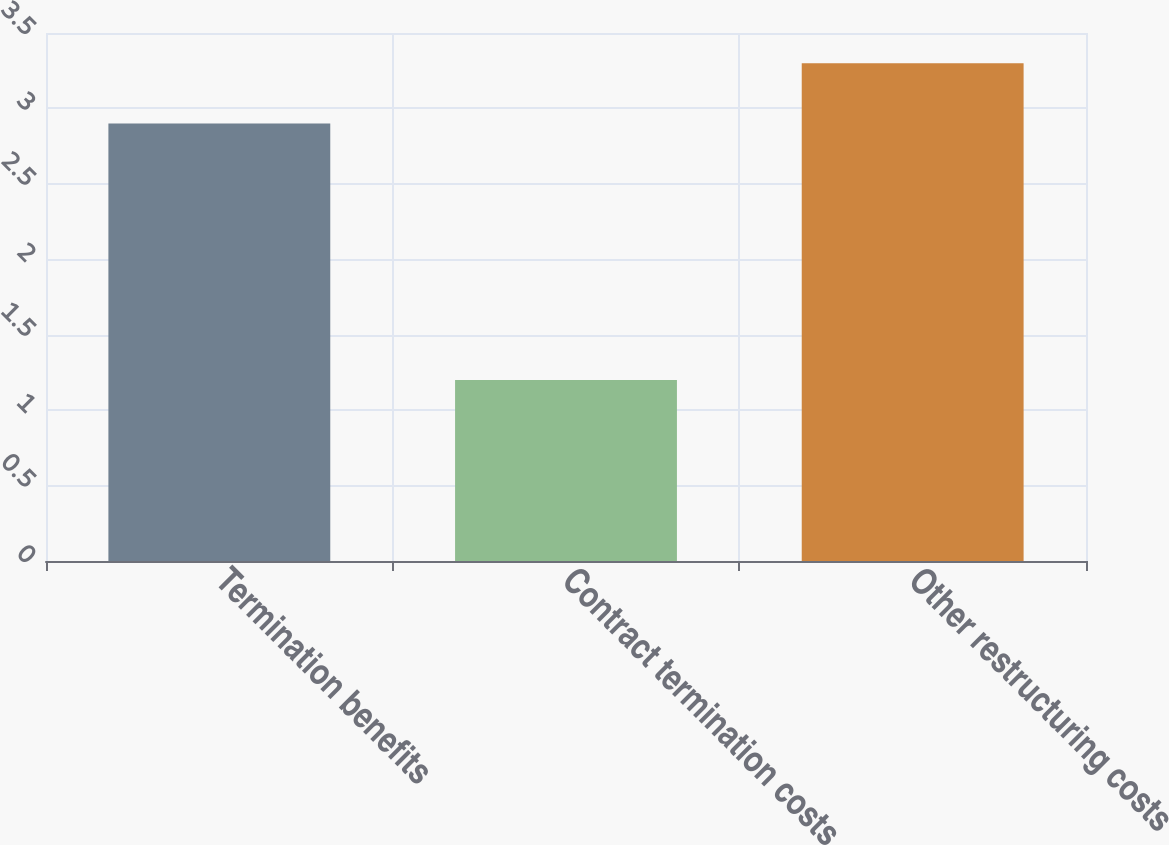Convert chart to OTSL. <chart><loc_0><loc_0><loc_500><loc_500><bar_chart><fcel>Termination benefits<fcel>Contract termination costs<fcel>Other restructuring costs<nl><fcel>2.9<fcel>1.2<fcel>3.3<nl></chart> 